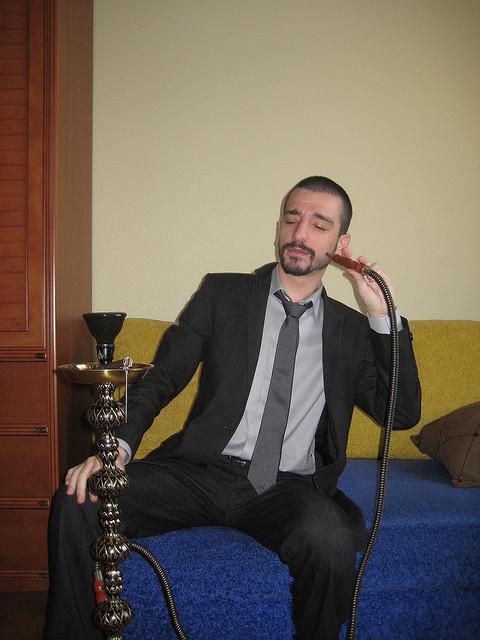How many hot dogs are in this picture?
Give a very brief answer. 0. 